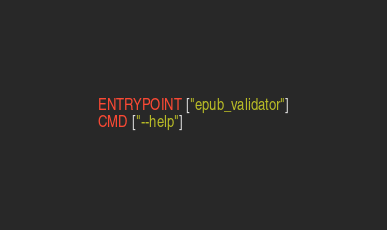<code> <loc_0><loc_0><loc_500><loc_500><_Dockerfile_>
ENTRYPOINT ["epub_validator"]
CMD ["--help"]
</code> 